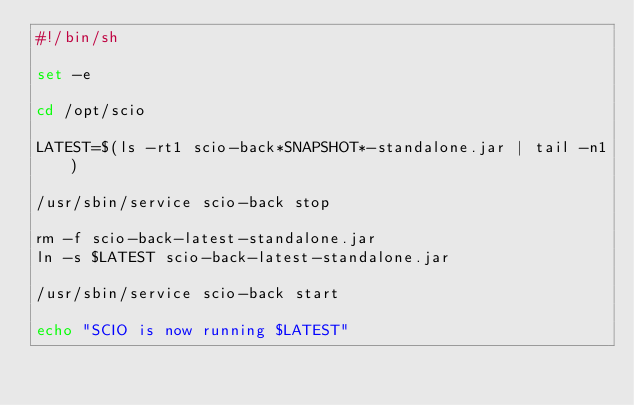<code> <loc_0><loc_0><loc_500><loc_500><_Bash_>#!/bin/sh

set -e

cd /opt/scio

LATEST=$(ls -rt1 scio-back*SNAPSHOT*-standalone.jar | tail -n1)

/usr/sbin/service scio-back stop

rm -f scio-back-latest-standalone.jar
ln -s $LATEST scio-back-latest-standalone.jar

/usr/sbin/service scio-back start

echo "SCIO is now running $LATEST"
</code> 